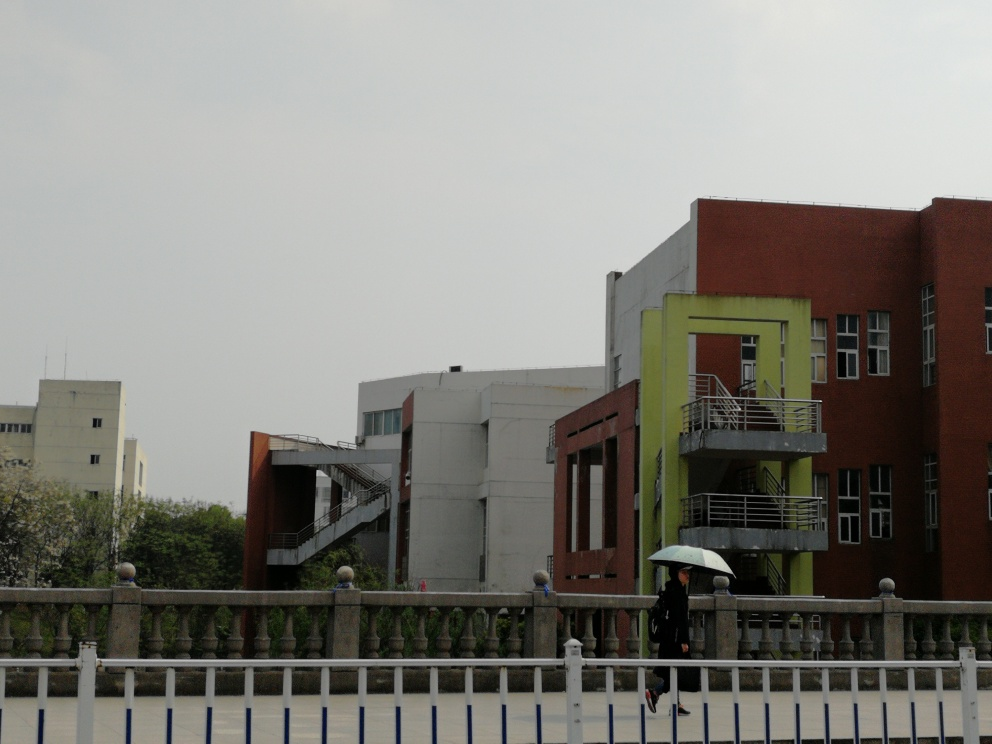Can you describe the weather conditions in the scene? The weather in the image seems overcast with gray skies, suggesting it might be a rainy or cloudy day. This assertion is supported by the presence of a person walking with an open umbrella. 